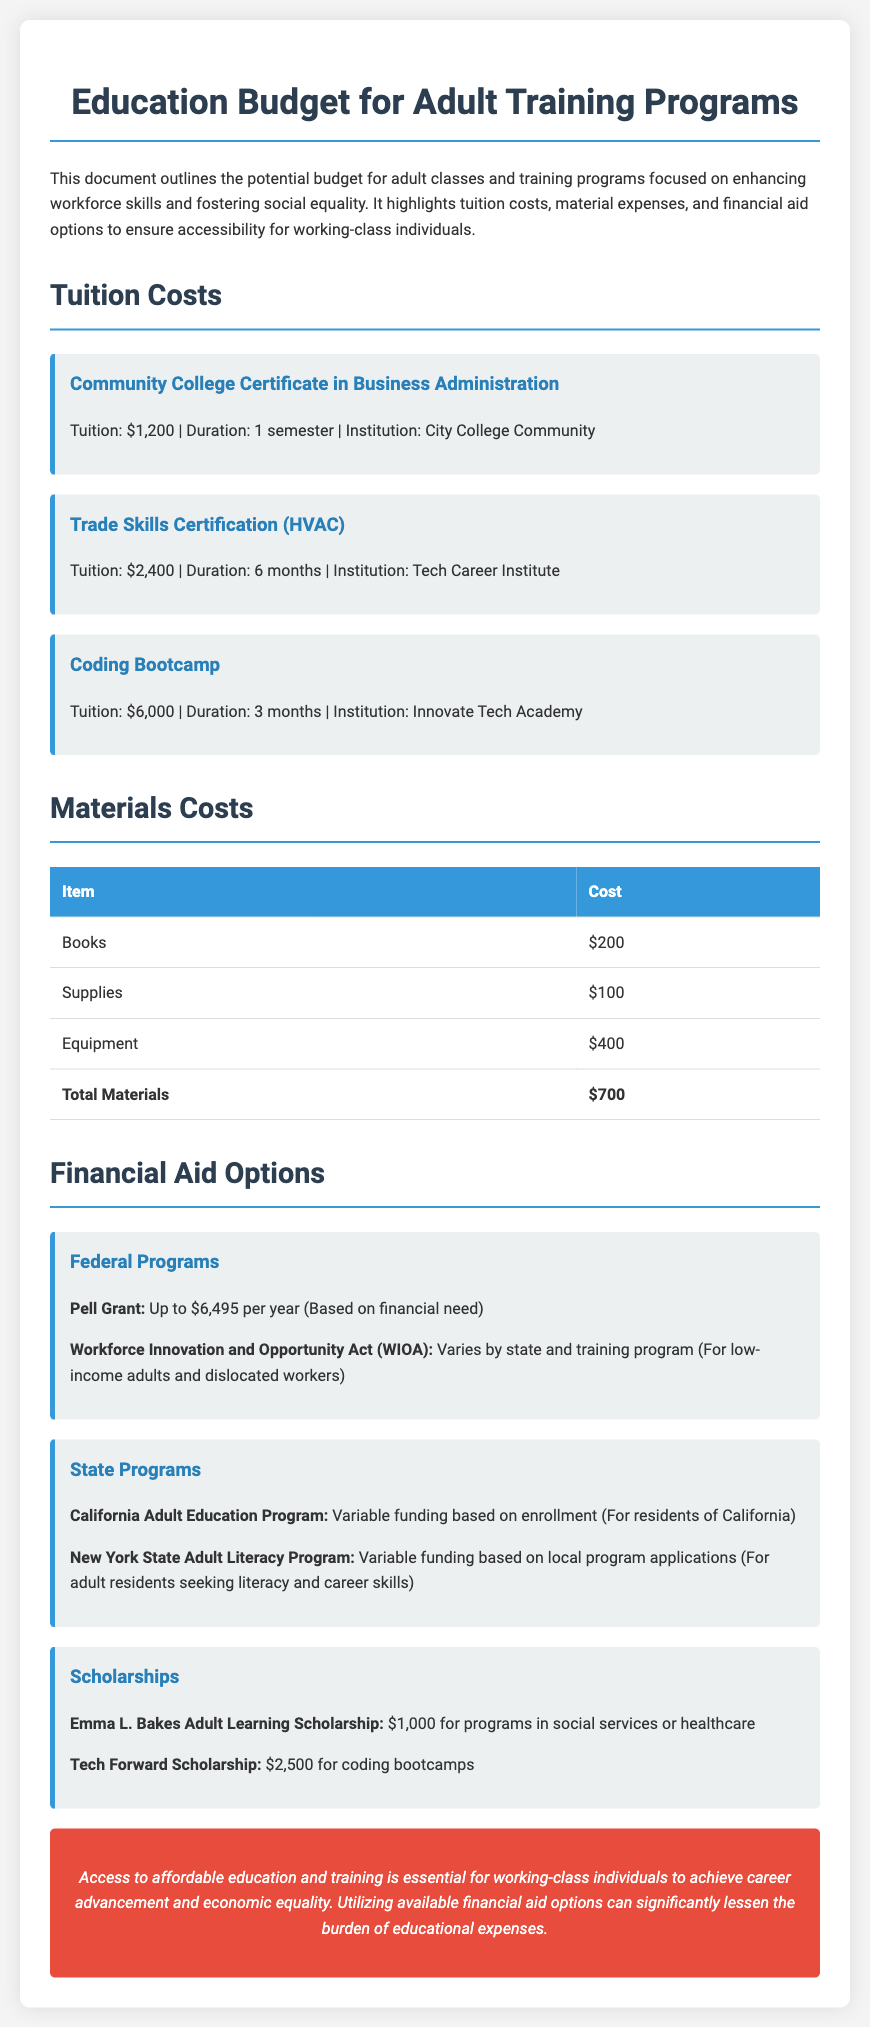What is the tuition for the Community College Certificate in Business Administration? The tuition listed for this program in the document is $1,200.
Answer: $1,200 What is the total cost for materials? The total materials cost calculated in the document is $700, which is the sum of the individual items listed.
Answer: $700 How much is allocated for the Coding Bootcamp? The document specifies a tuition of $6,000 for the Coding Bootcamp program.
Answer: $6,000 What type of scholarship is available for coding bootcamps? The document mentions the Tech Forward Scholarship for $2,500 specifically for coding bootcamps.
Answer: $2,500 What is the maximum amount for a Pell Grant? The document states that the maximum amount available for the Pell Grant is up to $6,495 per year.
Answer: $6,495 What financial aid program is variable based on state and training program? The Workforce Innovation and Opportunity Act (WIOA) is the financial aid program mentioned that varies by state and training program.
Answer: WIOA How much is the tuition for the Trade Skills Certification? The tuition for the Trade Skills Certification (HVAC) is listed as $2,400 in the document.
Answer: $2,400 What is the purpose of adult education programs according to the document? The document outlines that access to affordable education and training is essential for achieving career advancement and economic equality.
Answer: Career advancement and economic equality 